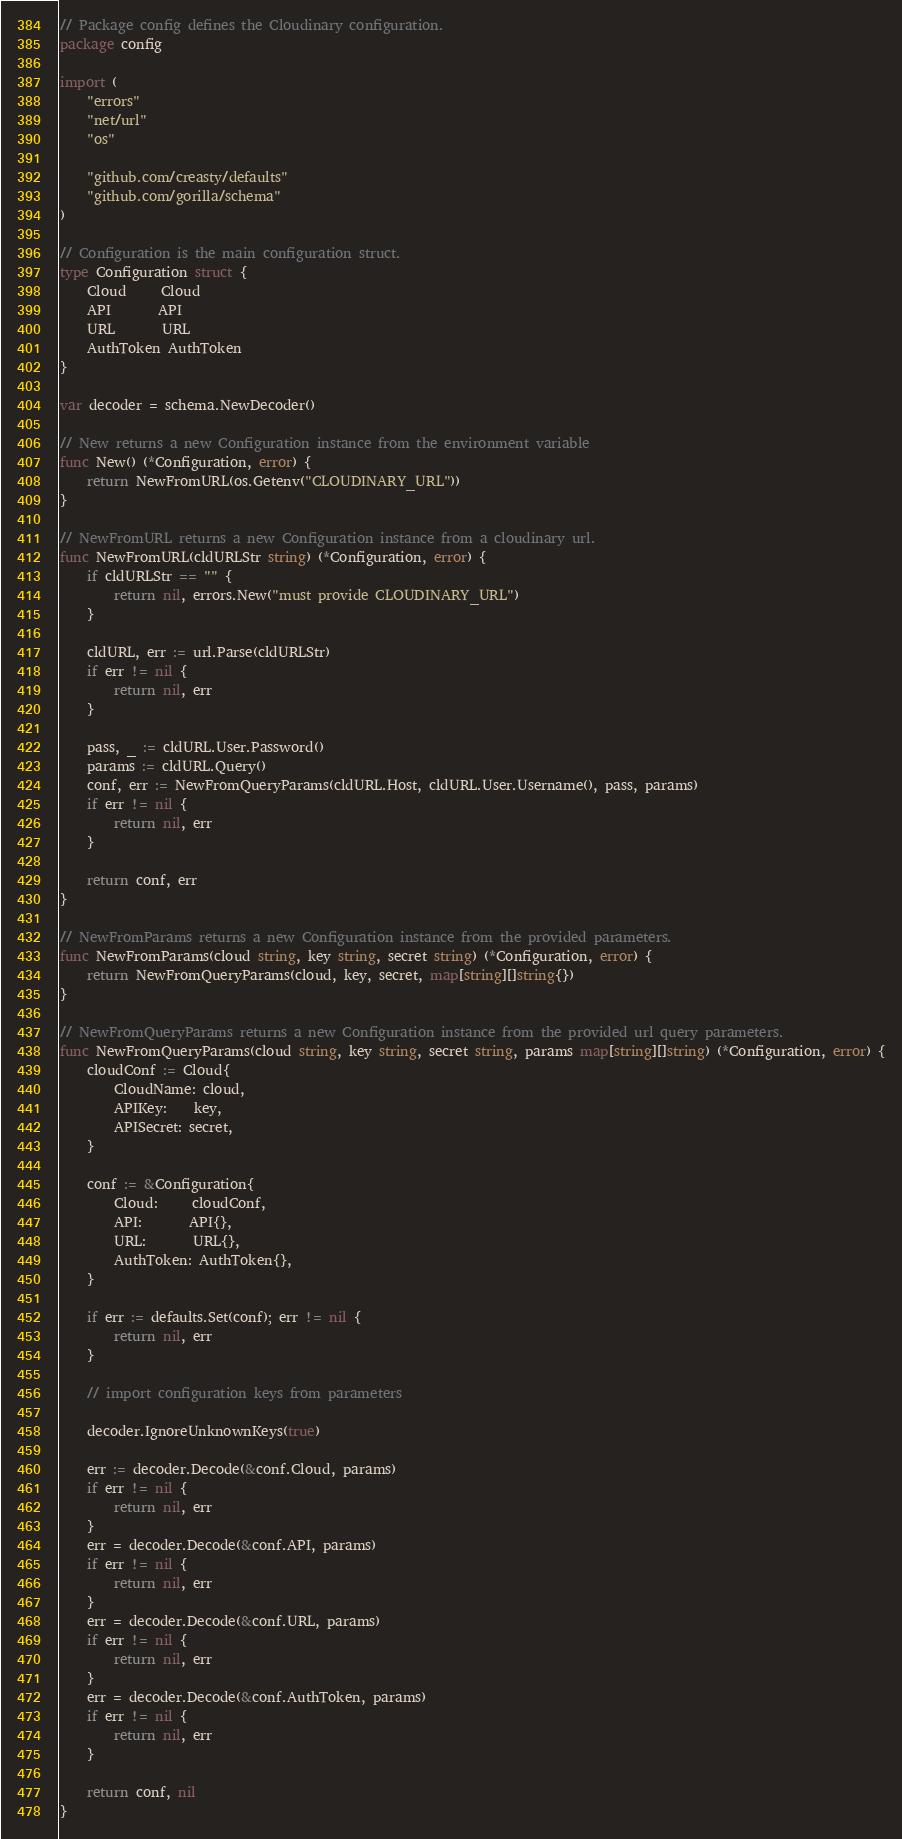Convert code to text. <code><loc_0><loc_0><loc_500><loc_500><_Go_>// Package config defines the Cloudinary configuration.
package config

import (
	"errors"
	"net/url"
	"os"

	"github.com/creasty/defaults"
	"github.com/gorilla/schema"
)

// Configuration is the main configuration struct.
type Configuration struct {
	Cloud     Cloud
	API       API
	URL       URL
	AuthToken AuthToken
}

var decoder = schema.NewDecoder()

// New returns a new Configuration instance from the environment variable
func New() (*Configuration, error) {
	return NewFromURL(os.Getenv("CLOUDINARY_URL"))
}

// NewFromURL returns a new Configuration instance from a cloudinary url.
func NewFromURL(cldURLStr string) (*Configuration, error) {
	if cldURLStr == "" {
		return nil, errors.New("must provide CLOUDINARY_URL")
	}

	cldURL, err := url.Parse(cldURLStr)
	if err != nil {
		return nil, err
	}

	pass, _ := cldURL.User.Password()
	params := cldURL.Query()
	conf, err := NewFromQueryParams(cldURL.Host, cldURL.User.Username(), pass, params)
	if err != nil {
		return nil, err
	}

	return conf, err
}

// NewFromParams returns a new Configuration instance from the provided parameters.
func NewFromParams(cloud string, key string, secret string) (*Configuration, error) {
	return NewFromQueryParams(cloud, key, secret, map[string][]string{})
}

// NewFromQueryParams returns a new Configuration instance from the provided url query parameters.
func NewFromQueryParams(cloud string, key string, secret string, params map[string][]string) (*Configuration, error) {
	cloudConf := Cloud{
		CloudName: cloud,
		APIKey:    key,
		APISecret: secret,
	}

	conf := &Configuration{
		Cloud:     cloudConf,
		API:       API{},
		URL:       URL{},
		AuthToken: AuthToken{},
	}

	if err := defaults.Set(conf); err != nil {
		return nil, err
	}

	// import configuration keys from parameters

	decoder.IgnoreUnknownKeys(true)

	err := decoder.Decode(&conf.Cloud, params)
	if err != nil {
		return nil, err
	}
	err = decoder.Decode(&conf.API, params)
	if err != nil {
		return nil, err
	}
	err = decoder.Decode(&conf.URL, params)
	if err != nil {
		return nil, err
	}
	err = decoder.Decode(&conf.AuthToken, params)
	if err != nil {
		return nil, err
	}

	return conf, nil
}
</code> 